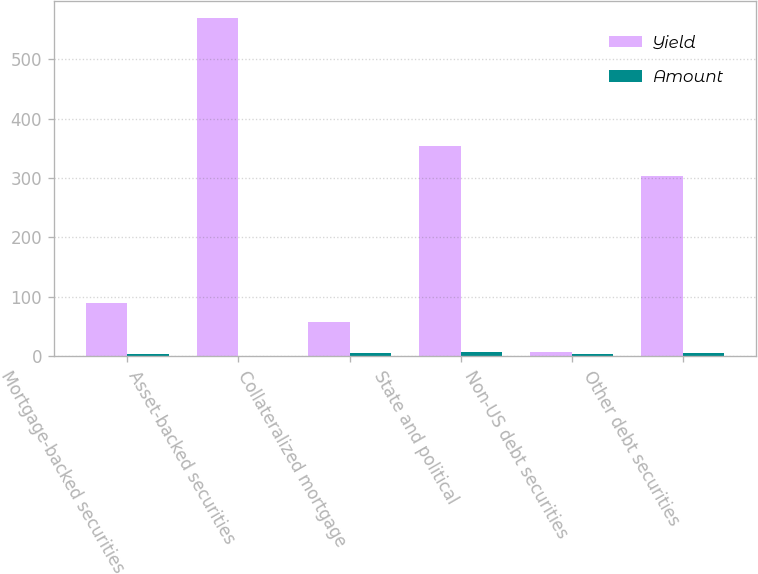<chart> <loc_0><loc_0><loc_500><loc_500><stacked_bar_chart><ecel><fcel>Mortgage-backed securities<fcel>Asset-backed securities<fcel>Collateralized mortgage<fcel>State and political<fcel>Non-US debt securities<fcel>Other debt securities<nl><fcel>Yield<fcel>89<fcel>569<fcel>58<fcel>354<fcel>6.65<fcel>303<nl><fcel>Amount<fcel>4.16<fcel>1.36<fcel>5.26<fcel>6.65<fcel>3.34<fcel>5.22<nl></chart> 